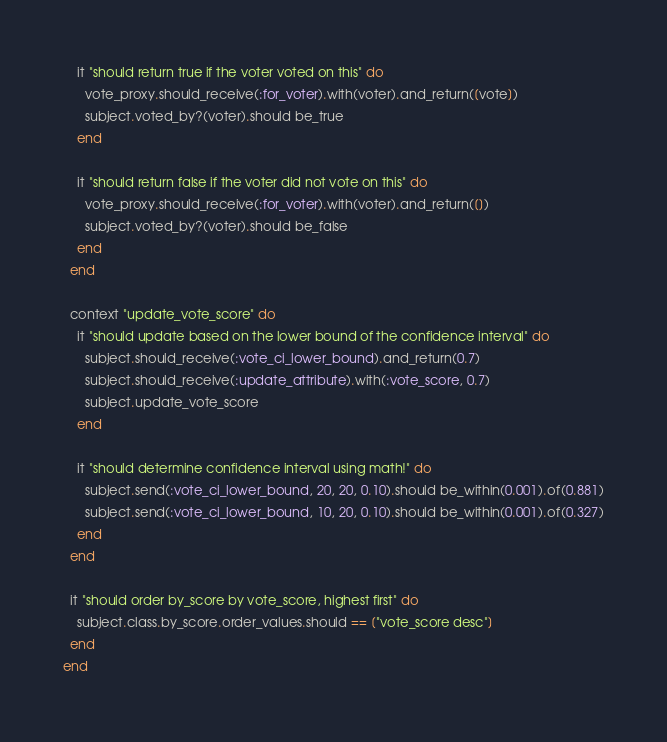Convert code to text. <code><loc_0><loc_0><loc_500><loc_500><_Ruby_>    it "should return true if the voter voted on this" do
      vote_proxy.should_receive(:for_voter).with(voter).and_return([vote])
      subject.voted_by?(voter).should be_true
    end

    it "should return false if the voter did not vote on this" do
      vote_proxy.should_receive(:for_voter).with(voter).and_return([])
      subject.voted_by?(voter).should be_false
    end
  end

  context "update_vote_score" do
    it "should update based on the lower bound of the confidence interval" do
      subject.should_receive(:vote_ci_lower_bound).and_return(0.7)
      subject.should_receive(:update_attribute).with(:vote_score, 0.7)
      subject.update_vote_score
    end

    it "should determine confidence interval using math!" do
      subject.send(:vote_ci_lower_bound, 20, 20, 0.10).should be_within(0.001).of(0.881)
      subject.send(:vote_ci_lower_bound, 10, 20, 0.10).should be_within(0.001).of(0.327)
    end
  end

  it "should order by_score by vote_score, highest first" do
    subject.class.by_score.order_values.should == ["vote_score desc"]
  end
end
</code> 